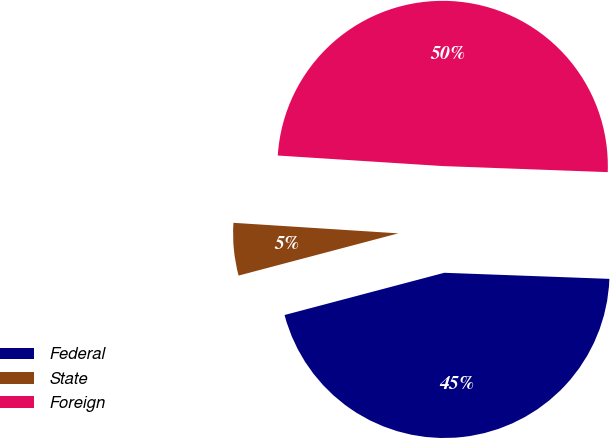<chart> <loc_0><loc_0><loc_500><loc_500><pie_chart><fcel>Federal<fcel>State<fcel>Foreign<nl><fcel>45.3%<fcel>5.13%<fcel>49.57%<nl></chart> 